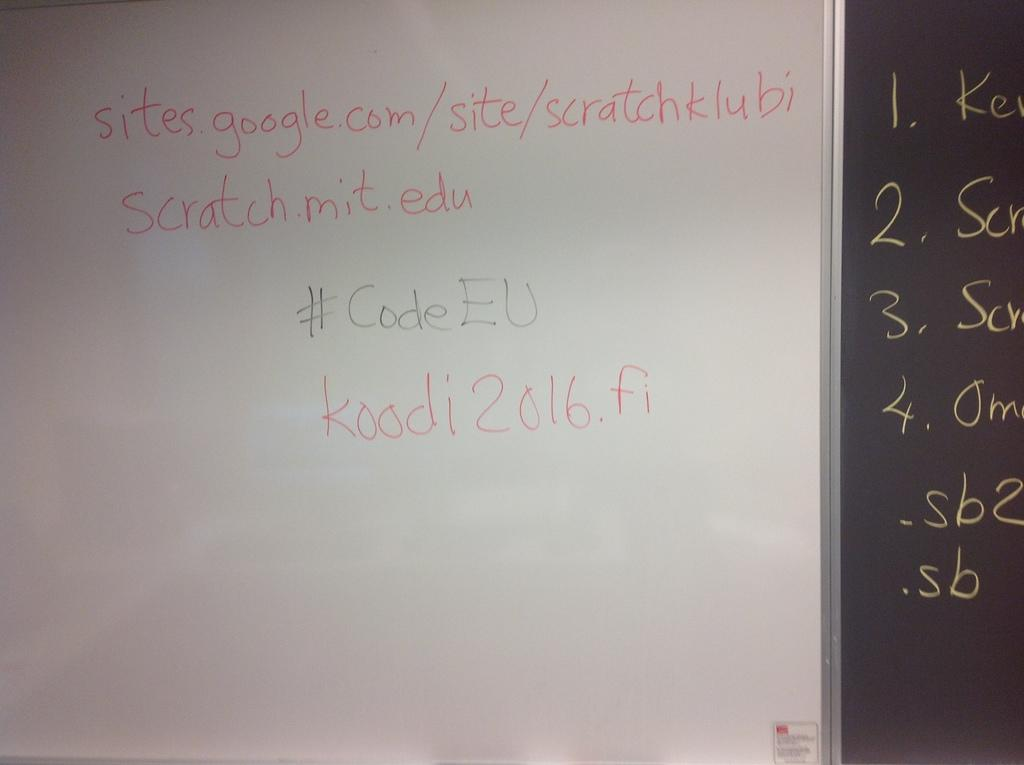<image>
Summarize the visual content of the image. A white board with writing on it that discusses sites on Google. 